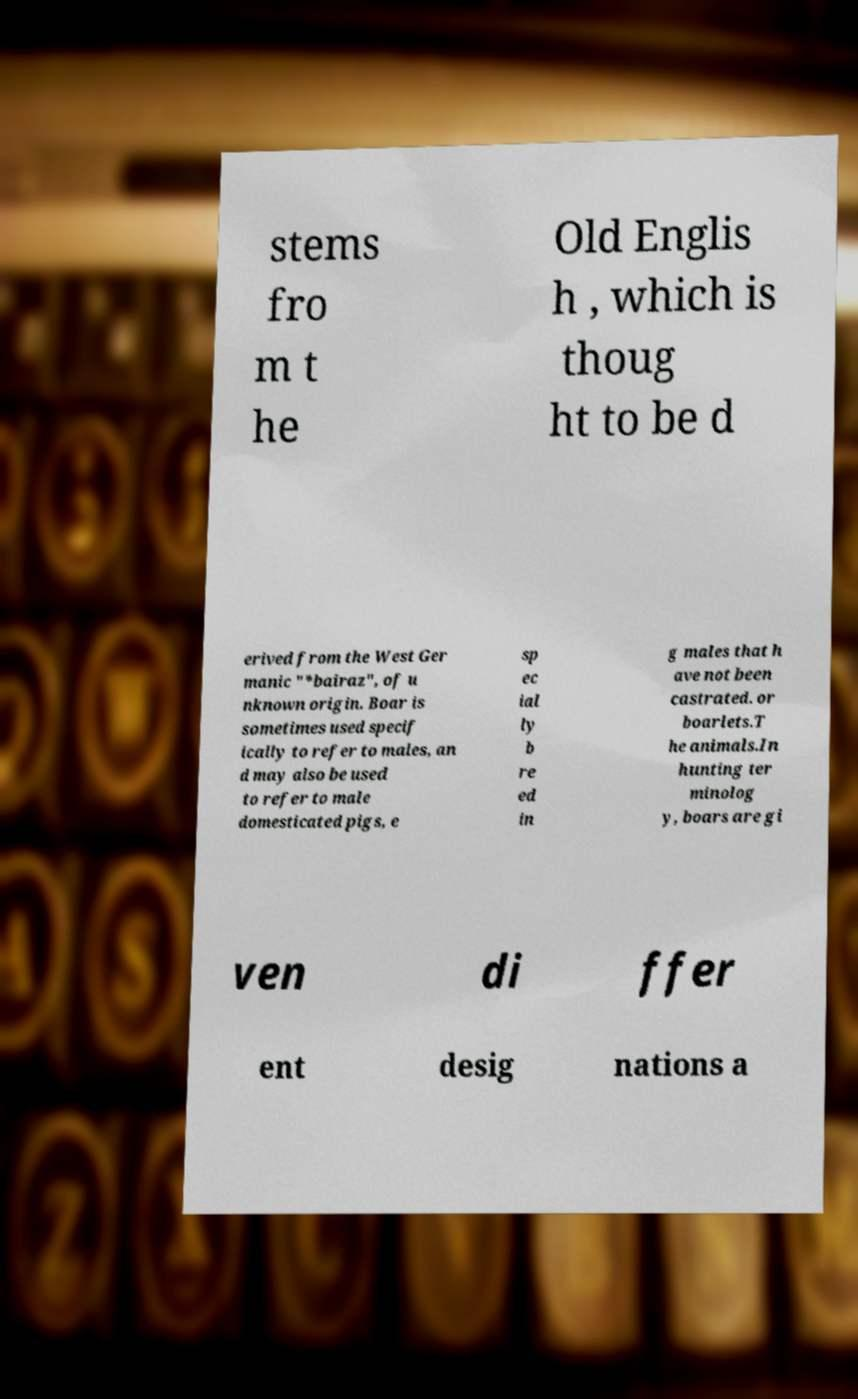Please read and relay the text visible in this image. What does it say? stems fro m t he Old Englis h , which is thoug ht to be d erived from the West Ger manic "*bairaz", of u nknown origin. Boar is sometimes used specif ically to refer to males, an d may also be used to refer to male domesticated pigs, e sp ec ial ly b re ed in g males that h ave not been castrated. or boarlets.T he animals.In hunting ter minolog y, boars are gi ven di ffer ent desig nations a 